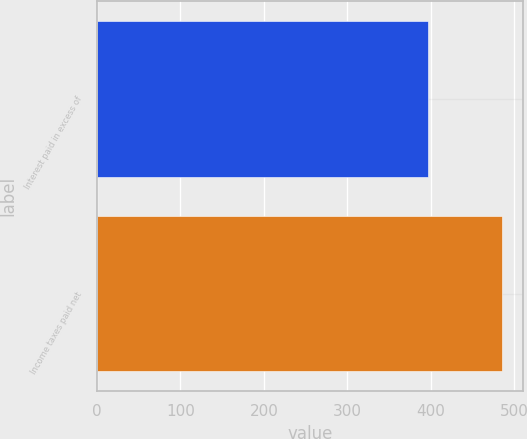Convert chart. <chart><loc_0><loc_0><loc_500><loc_500><bar_chart><fcel>Interest paid in excess of<fcel>Income taxes paid net<nl><fcel>397<fcel>486<nl></chart> 